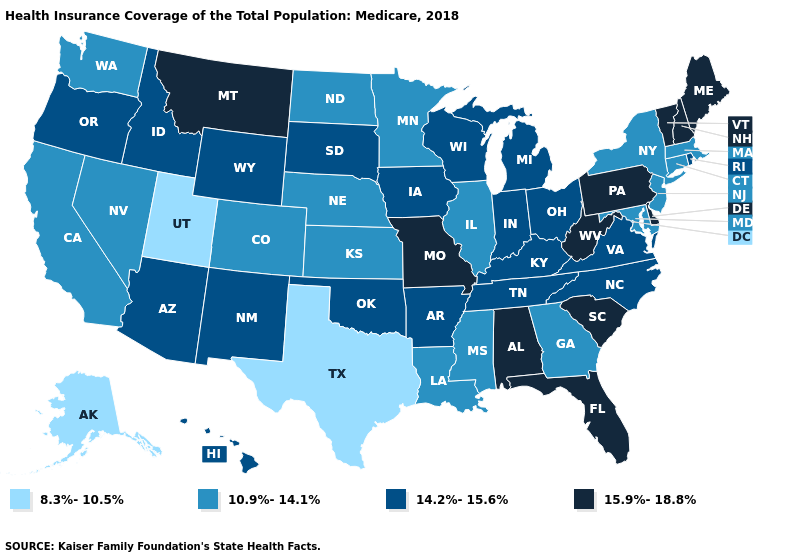What is the value of Mississippi?
Be succinct. 10.9%-14.1%. Does the map have missing data?
Be succinct. No. What is the value of Nebraska?
Give a very brief answer. 10.9%-14.1%. Does the map have missing data?
Keep it brief. No. Among the states that border Tennessee , does Missouri have the highest value?
Short answer required. Yes. Which states have the lowest value in the USA?
Answer briefly. Alaska, Texas, Utah. What is the value of Pennsylvania?
Answer briefly. 15.9%-18.8%. What is the value of Missouri?
Quick response, please. 15.9%-18.8%. What is the value of West Virginia?
Keep it brief. 15.9%-18.8%. Does South Carolina have the lowest value in the South?
Keep it brief. No. Among the states that border Massachusetts , does New Hampshire have the highest value?
Be succinct. Yes. Does Pennsylvania have a higher value than West Virginia?
Answer briefly. No. What is the value of Massachusetts?
Concise answer only. 10.9%-14.1%. What is the value of Indiana?
Quick response, please. 14.2%-15.6%. What is the lowest value in the USA?
Quick response, please. 8.3%-10.5%. 